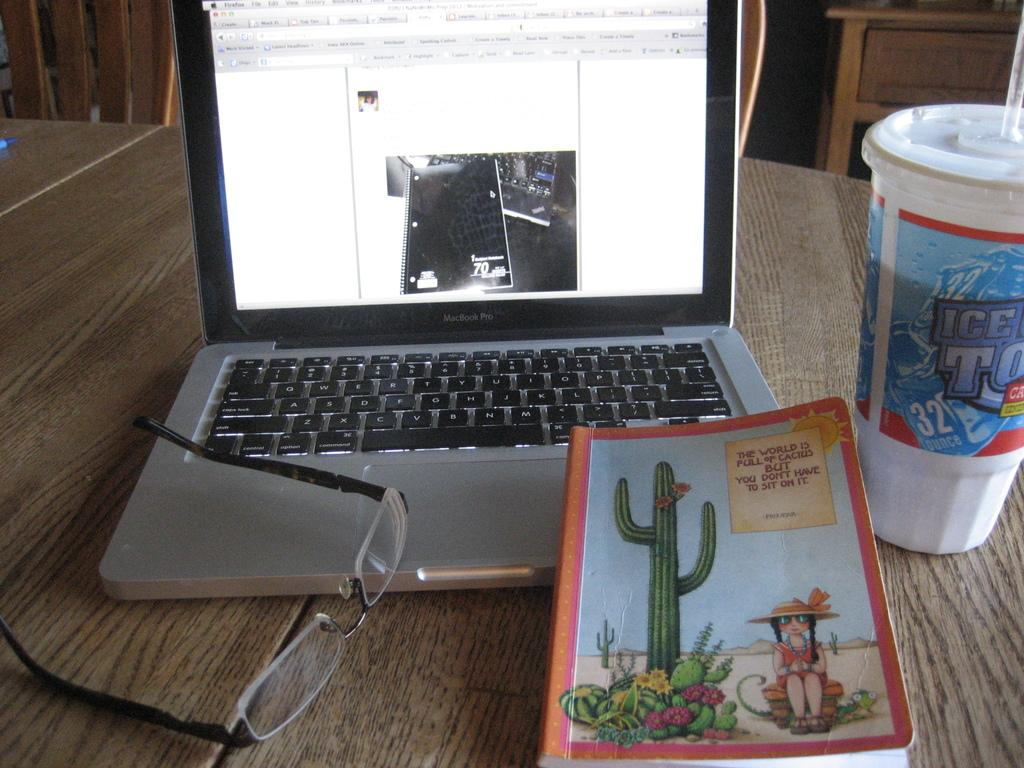What electronic device is visible in the image? There is a laptop in the image. What non-electronic item can be seen in the image? There is a book in the image. What type of container is present in the image? There is a cup in the image. What additional object is visible in the image? There are specs in the image. Where are all these objects placed? All these objects are placed on a table. What type of furniture is visible in the top right corner of the image? There is a cupboard in the top right corner of the image. How many feathers are on the bed in the image? There is no bed present in the image, so it is not possible to determine the number of feathers on it. 